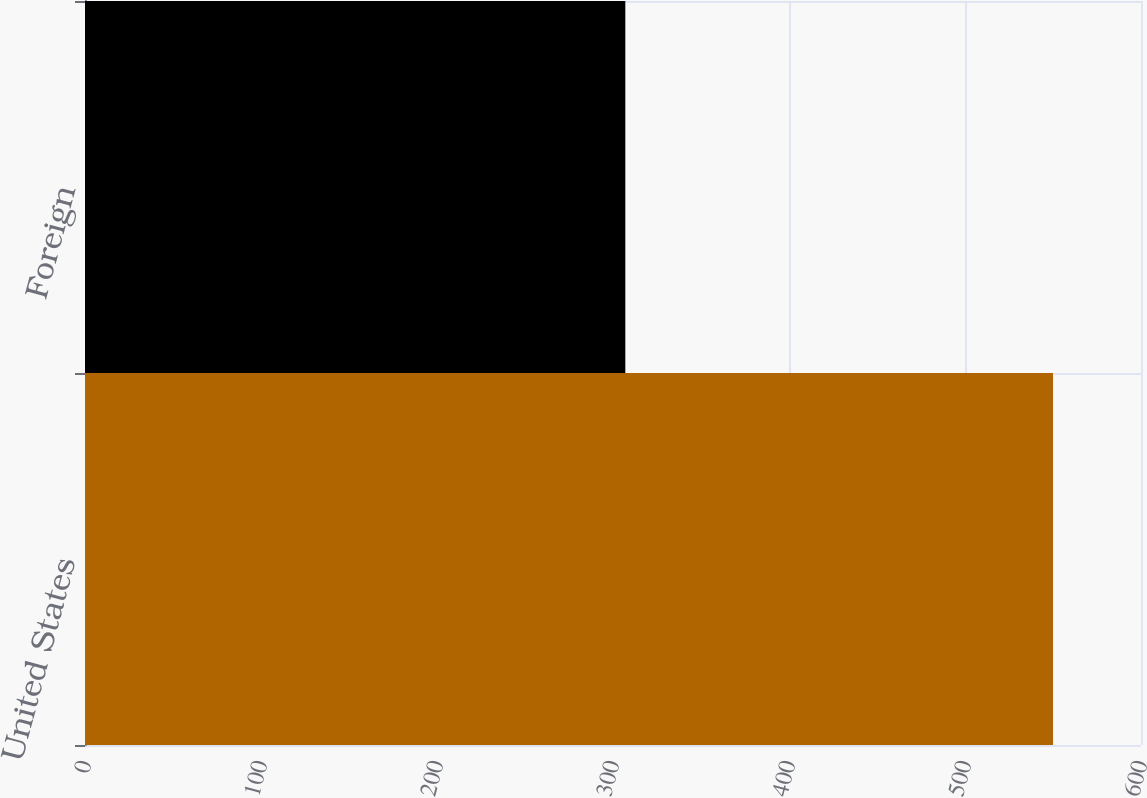<chart> <loc_0><loc_0><loc_500><loc_500><bar_chart><fcel>United States<fcel>Foreign<nl><fcel>550<fcel>307<nl></chart> 